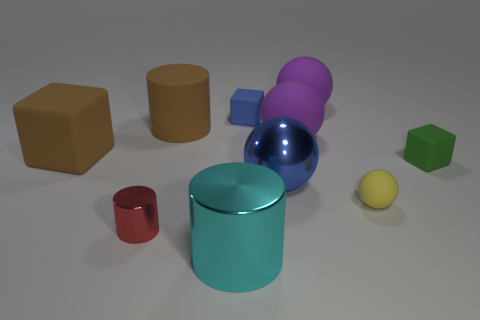The brown object to the right of the large brown rubber object that is to the left of the small red object is made of what material?
Your answer should be very brief. Rubber. There is another big object that is the same shape as the cyan shiny thing; what material is it?
Your answer should be compact. Rubber. There is a big thing in front of the blue object in front of the green cube; are there any tiny cubes that are right of it?
Offer a very short reply. Yes. What number of other objects are there of the same color as the tiny shiny thing?
Your answer should be very brief. 0. How many big things are both to the left of the small metal thing and in front of the metal ball?
Give a very brief answer. 0. What is the shape of the small shiny object?
Offer a terse response. Cylinder. What number of other objects are the same material as the yellow thing?
Make the answer very short. 6. What is the color of the matte thing that is to the left of the large cylinder on the left side of the large metal thing that is in front of the blue sphere?
Offer a terse response. Brown. There is a brown cylinder that is the same size as the cyan shiny cylinder; what is its material?
Provide a succinct answer. Rubber. How many objects are either matte spheres in front of the blue ball or small blue rubber blocks?
Make the answer very short. 2. 